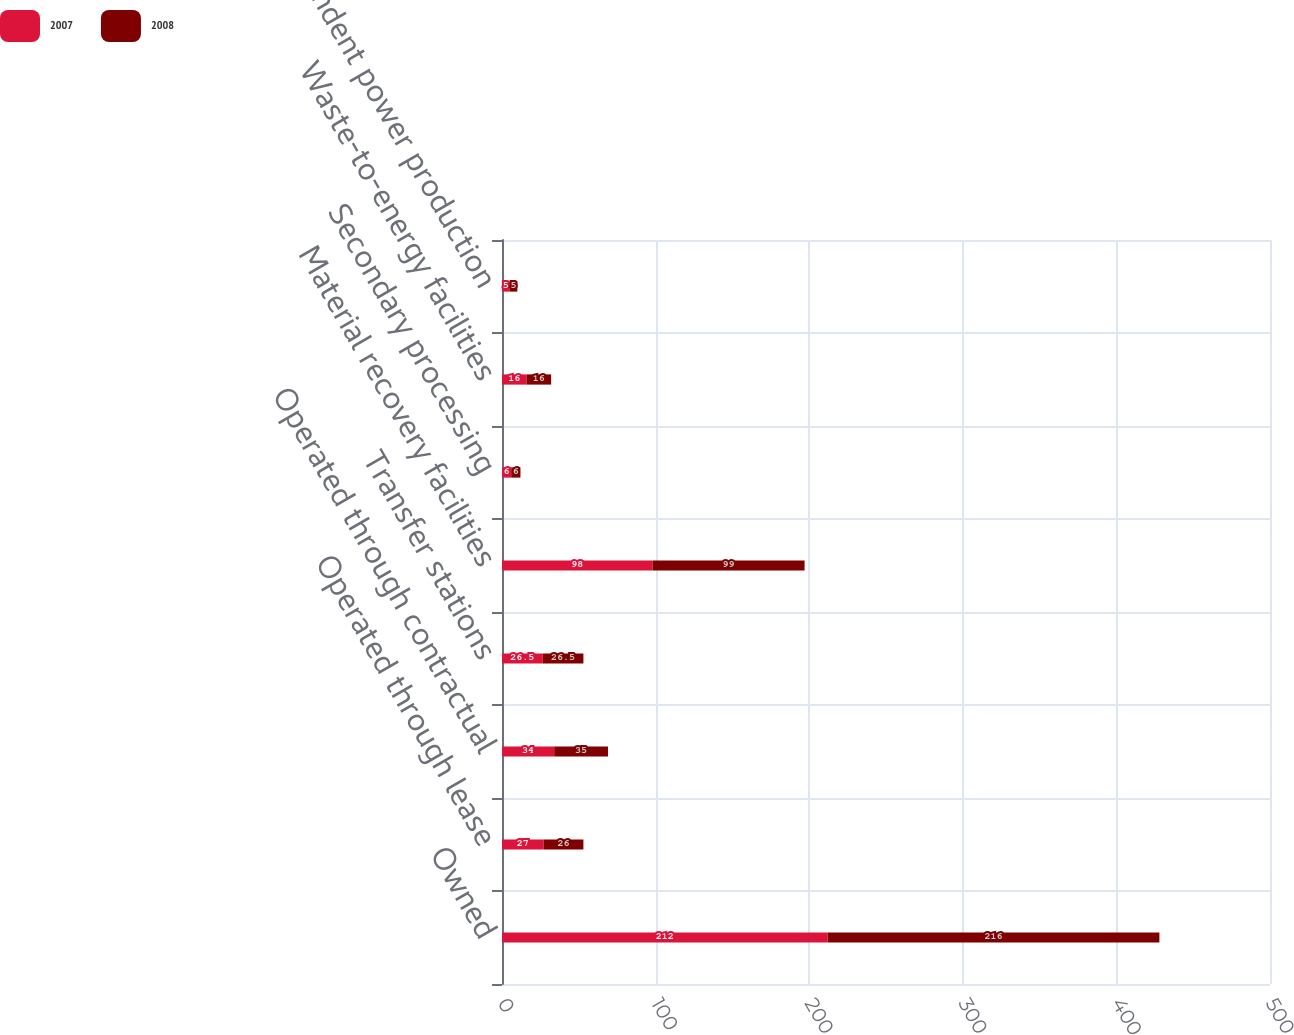<chart> <loc_0><loc_0><loc_500><loc_500><stacked_bar_chart><ecel><fcel>Owned<fcel>Operated through lease<fcel>Operated through contractual<fcel>Transfer stations<fcel>Material recovery facilities<fcel>Secondary processing<fcel>Waste-to-energy facilities<fcel>Independent power production<nl><fcel>2007<fcel>212<fcel>27<fcel>34<fcel>26.5<fcel>98<fcel>6<fcel>16<fcel>5<nl><fcel>2008<fcel>216<fcel>26<fcel>35<fcel>26.5<fcel>99<fcel>6<fcel>16<fcel>5<nl></chart> 